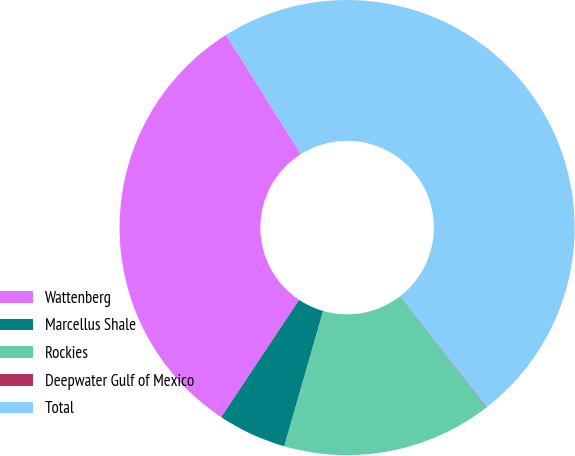Convert chart to OTSL. <chart><loc_0><loc_0><loc_500><loc_500><pie_chart><fcel>Wattenberg<fcel>Marcellus Shale<fcel>Rockies<fcel>Deepwater Gulf of Mexico<fcel>Total<nl><fcel>31.74%<fcel>4.88%<fcel>14.92%<fcel>0.04%<fcel>48.42%<nl></chart> 